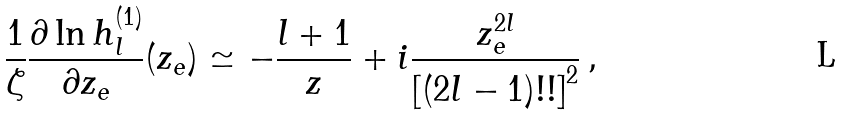<formula> <loc_0><loc_0><loc_500><loc_500>\frac { 1 } { \zeta } \frac { \partial \ln h ^ { ( 1 ) } _ { l } } { \partial z _ { e } } ( z _ { e } ) \simeq - \frac { l + 1 } { z } + i \frac { z _ { e } ^ { 2 l } } { \left [ ( 2 l - 1 ) ! ! \right ] ^ { 2 } } \, ,</formula> 